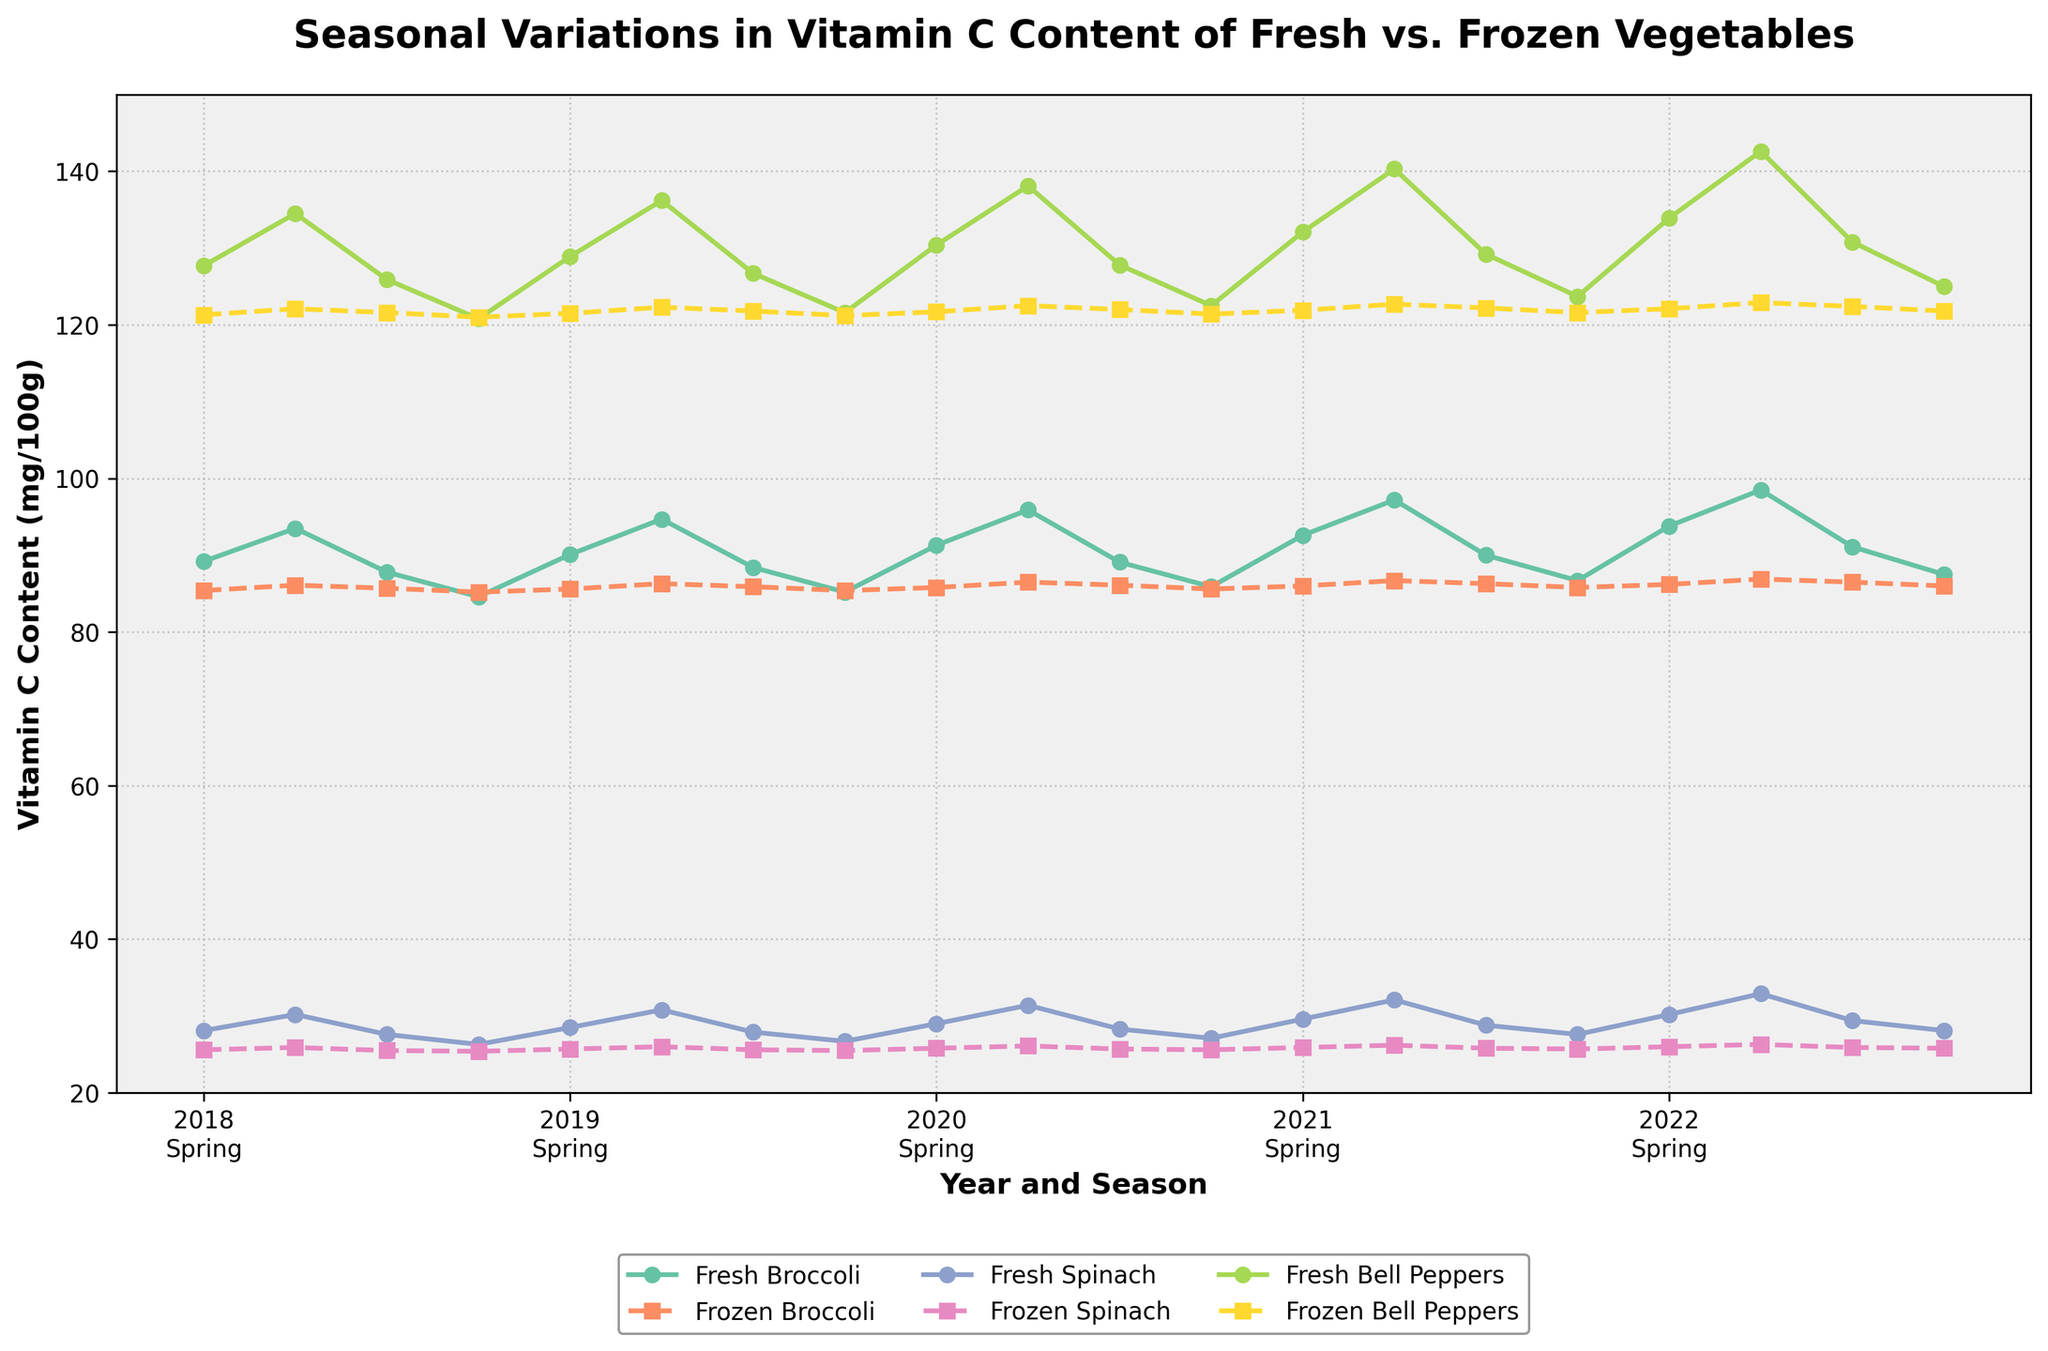What is the highest vitamin C content observed in fresh vegetables across all seasons and years? To find the highest vitamin C content in fresh vegetables, we look at the peak points of the lines representing fresh broccoli, fresh spinach, and fresh bell peppers. Fresh Bell Peppers in Summer 2022 holds the maximum value which is 142.6 mg/100g.
Answer: 142.6 mg/100g Which type of vegetable showed the least variation in vitamin C content between fresh and frozen forms? To determine the vegetable with the least variation, observe the proximity of the solid and dashed lines for each vegetable. Both fresh and frozen spinach lines remain very close across all years and seasons.
Answer: Spinach How did the vitamin C content of fresh broccoli in Winter 2020 compare to that of fresh bell peppers in Spring 2020? For comparison, trace the lines corresponding to fresh broccoli in Winter 2020 and fresh bell peppers in Spring 2020. Fresh broccoli had a content of 85.9 mg/100g while fresh bell peppers had 130.4 mg/100g.
Answer: Fresh Bell Peppers > Fresh Broccoli Does frozen broccoli in summer seasons consistently have higher vitamin C content than frozen spinach? Compare the vitamin C values of frozen broccoli and frozen spinach in summer seasons across the years. In every summer season from 2018 to 2022, frozen broccoli has higher values than frozen spinach.
Answer: Yes What is the average vitamin C content of fresh spinach during all spring seasons? To find the average vitamin C content, sum the fresh spinach values for all spring seasons and divide by 5: (28.1+28.5+29.0+29.6+30.2)/5 = 145.4/5 = 29.08
Answer: 29.08 mg/100g How often did fresh bell peppers exceed 130 mg/100g in any season? Check all seasonal points for fresh bell peppers (solid green line). Counts reveal that it exceeds 130 mg/100g thrice in Spring and all five times in Summer, summing up to seven times.
Answer: 7 times During which seasons is the vitamin C content for fresh broccoli higher than that of frozen broccoli? Observe the lines for fresh and frozen broccoli across all seasons and years. Fresh broccoli frequently exceeds frozen broccoli values in Spring and Summer seasons while in Fall and Winter they are occasionally lower or similar.
Answer: Spring and Summer What’s the difference in vitamin C content between fresh and frozen bell peppers in Summer 2021? Check the corresponding data points: fresh bell peppers in Summer 2021 are at 140.3 mg/100g, and frozen bell peppers are at 122.7 mg/100g. The difference is calculated as 140.3 - 122.7 = 17.6 mg/100g.
Answer: 17.6 mg/100g 